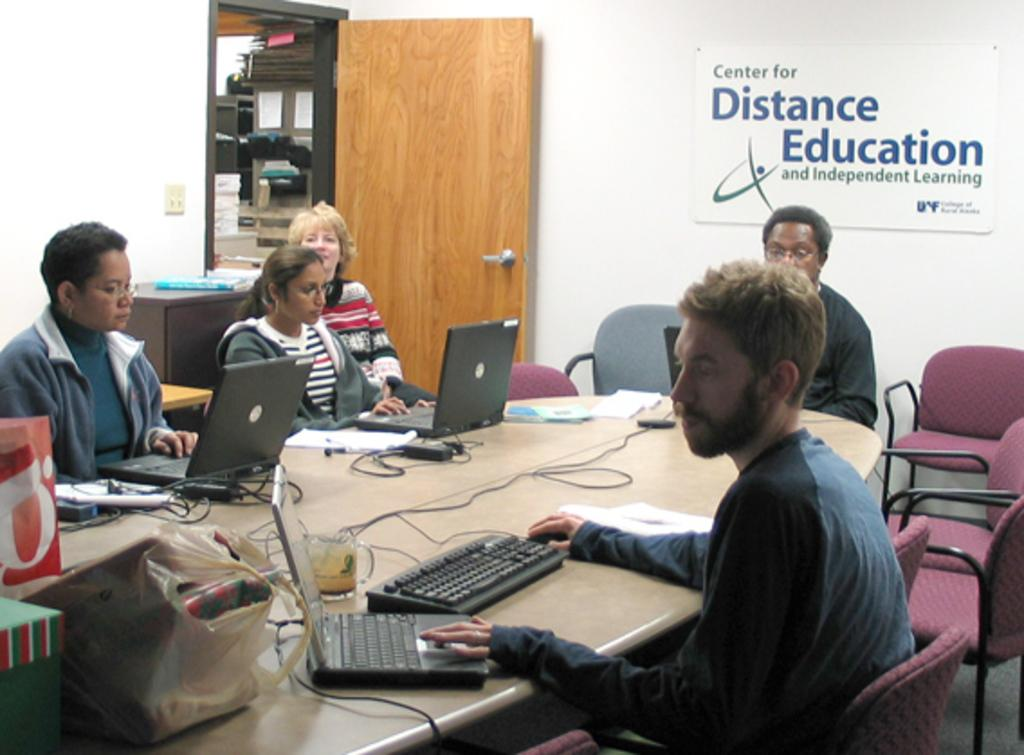<image>
Relay a brief, clear account of the picture shown. Several people work on laptops around a table at the Center for Distance Education and Independent Learning. 